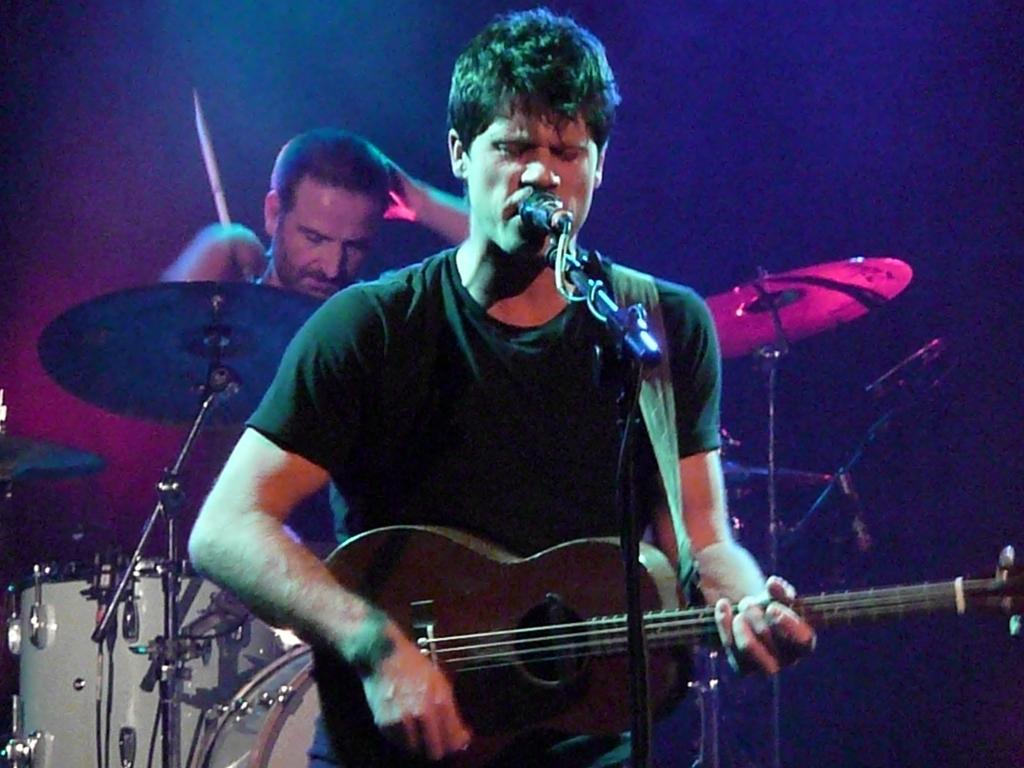What is the man in the image doing with the guitar? The man is standing and playing a guitar. What other activity is the man engaged in while playing the guitar? The man is singing and using a microphone. What other musical instrument can be seen in the image? There are drums visible in the image. What is the position of the man holding the drumstick? The man is standing holding a drumstick on his back. What causes the man's mind to fall while playing the guitar? There is no indication in the image that the man's mind is falling or that any cause for such an event is present. 